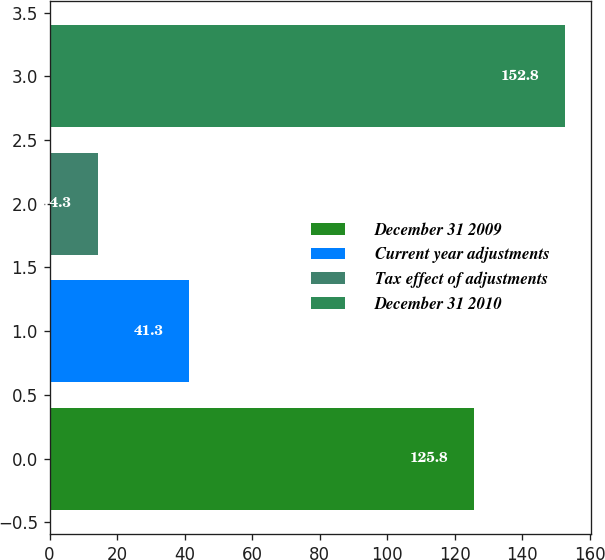<chart> <loc_0><loc_0><loc_500><loc_500><bar_chart><fcel>December 31 2009<fcel>Current year adjustments<fcel>Tax effect of adjustments<fcel>December 31 2010<nl><fcel>125.8<fcel>41.3<fcel>14.3<fcel>152.8<nl></chart> 